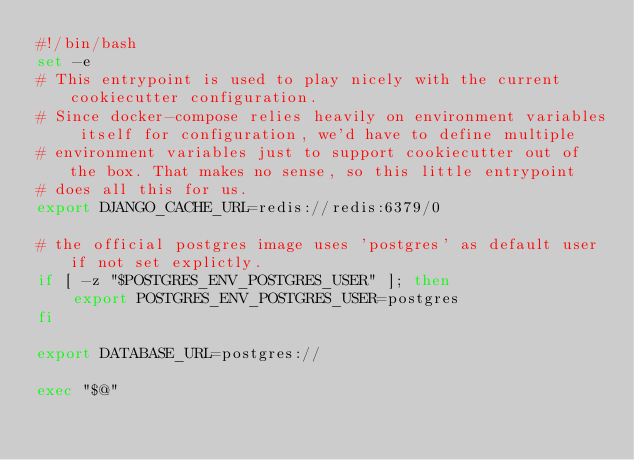<code> <loc_0><loc_0><loc_500><loc_500><_Bash_>#!/bin/bash
set -e
# This entrypoint is used to play nicely with the current cookiecutter configuration.
# Since docker-compose relies heavily on environment variables itself for configuration, we'd have to define multiple
# environment variables just to support cookiecutter out of the box. That makes no sense, so this little entrypoint
# does all this for us.
export DJANGO_CACHE_URL=redis://redis:6379/0

# the official postgres image uses 'postgres' as default user if not set explictly.
if [ -z "$POSTGRES_ENV_POSTGRES_USER" ]; then
    export POSTGRES_ENV_POSTGRES_USER=postgres
fi 

export DATABASE_URL=postgres://

exec "$@"
</code> 